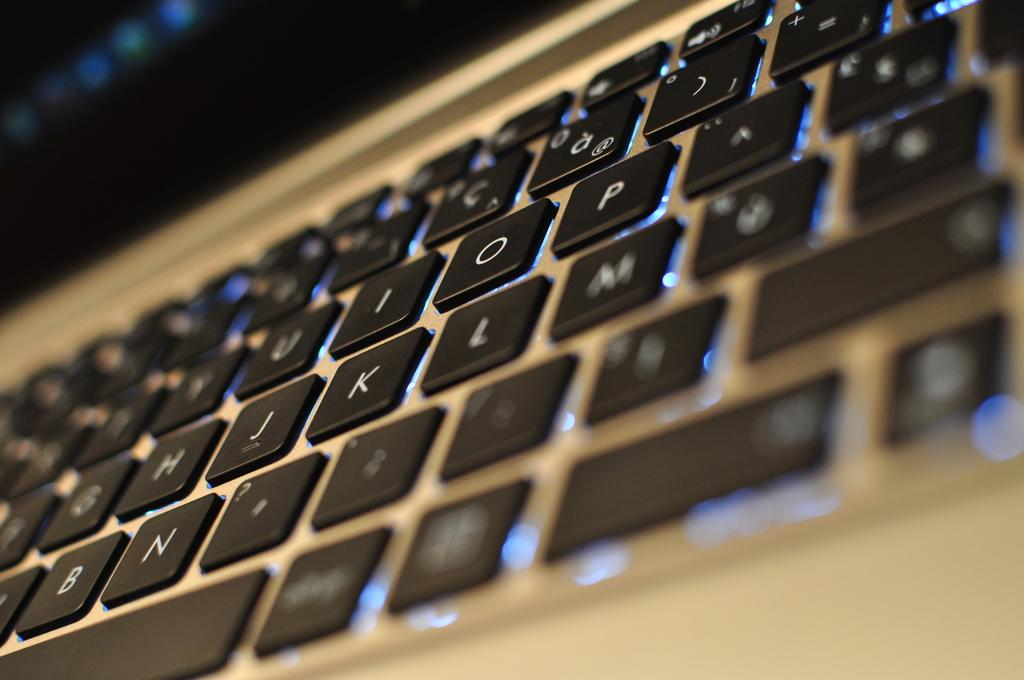<image>
Create a compact narrative representing the image presented. a backlit keyboard that has the letters n and j and k and l on them 